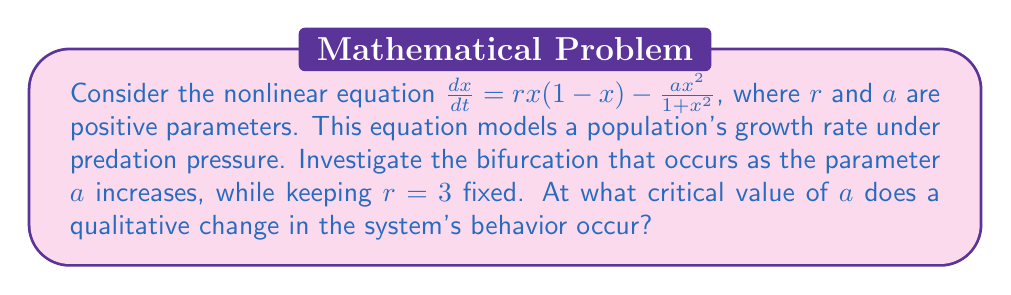Teach me how to tackle this problem. Let's approach this step-by-step:

1) First, we need to find the equilibrium points of the system. These occur when $\frac{dx}{dt} = 0$:

   $$rx(1-x) - \frac{ax^2}{1+x^2} = 0$$

2) Rearranging this equation:

   $$rx - rx^2 = \frac{ax^2}{1+x^2}$$

3) Multiplying both sides by $(1+x^2)$:

   $$rx(1+x^2) - rx^2(1+x^2) = ax^2$$

4) Expanding:

   $$rx + rx^3 - rx^2 - rx^4 = ax^2$$

5) Collecting terms:

   $$rx + rx^3 - (r+a)x^2 - rx^4 = 0$$

6) This is a complex equation. To simplify our analysis, let's focus on the trivial equilibrium point $x=0$, which always exists, and the potential bifurcation point where it changes stability.

7) The stability of $x=0$ is determined by the derivative of the right-hand side of the original equation, evaluated at $x=0$:

   $$\frac{d}{dx}\left(rx(1-x) - \frac{ax^2}{1+x^2}\right)\bigg|_{x=0} = r$$

8) The stability changes when this derivative equals zero. However, since $r$ is fixed at 3, this equilibrium point doesn't change stability for any value of $a$.

9) The next step would be to look for a transcritical bifurcation, where a non-zero equilibrium point collides with the zero equilibrium. This occurs when a non-zero root of the equation in step 5 approaches zero.

10) As $x$ approaches 0, the dominant terms in the equation from step 5 are:

    $$rx - (r+a)x^2 \approx 0$$

11) For small non-zero $x$, this is approximately satisfied when:

    $$r = r+a$$

12) This equation is satisfied when $a=0$, which is the critical point we're looking for.

Therefore, a transcritical bifurcation occurs at $a=0$, where a positive equilibrium point emerges from the zero equilibrium.
Answer: $a=0$ 